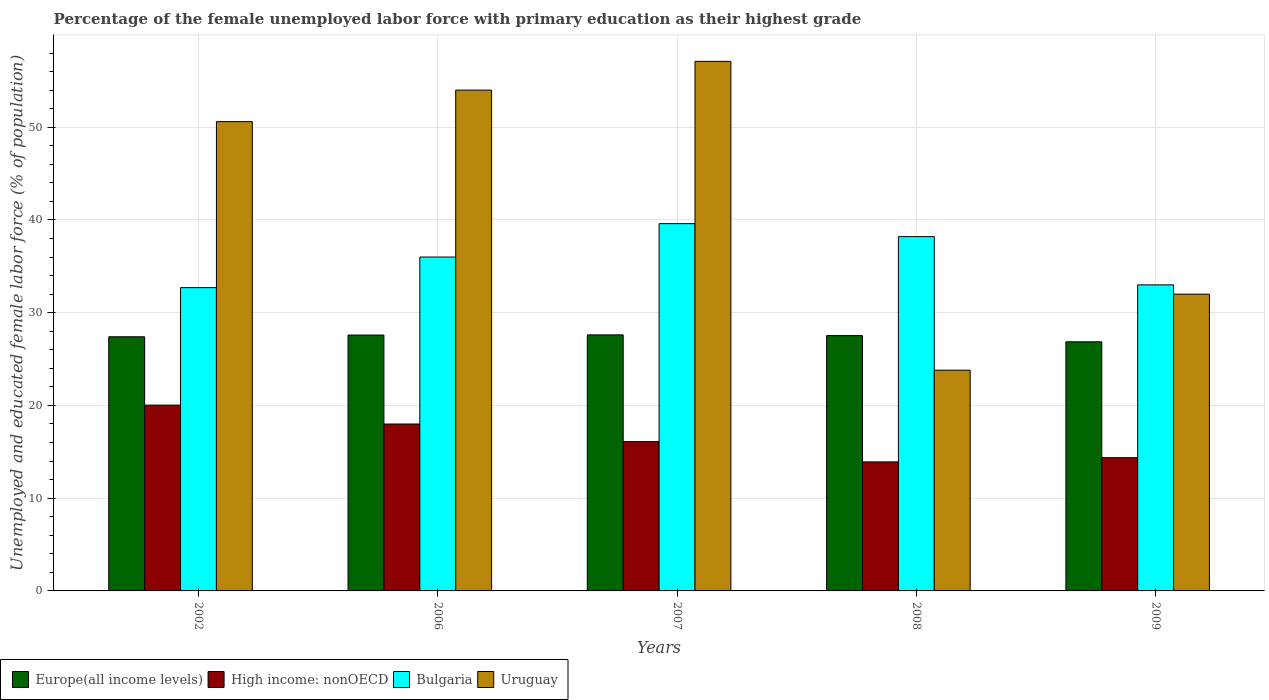How many different coloured bars are there?
Your answer should be very brief. 4. How many groups of bars are there?
Make the answer very short. 5. Are the number of bars on each tick of the X-axis equal?
Make the answer very short. Yes. How many bars are there on the 3rd tick from the right?
Ensure brevity in your answer.  4. What is the percentage of the unemployed female labor force with primary education in Bulgaria in 2002?
Provide a succinct answer. 32.7. Across all years, what is the maximum percentage of the unemployed female labor force with primary education in Uruguay?
Give a very brief answer. 57.1. Across all years, what is the minimum percentage of the unemployed female labor force with primary education in Uruguay?
Offer a terse response. 23.8. In which year was the percentage of the unemployed female labor force with primary education in Bulgaria maximum?
Provide a short and direct response. 2007. What is the total percentage of the unemployed female labor force with primary education in Europe(all income levels) in the graph?
Give a very brief answer. 136.99. What is the difference between the percentage of the unemployed female labor force with primary education in Uruguay in 2006 and that in 2009?
Give a very brief answer. 22. What is the difference between the percentage of the unemployed female labor force with primary education in Uruguay in 2007 and the percentage of the unemployed female labor force with primary education in Bulgaria in 2009?
Offer a terse response. 24.1. What is the average percentage of the unemployed female labor force with primary education in Europe(all income levels) per year?
Provide a succinct answer. 27.4. In the year 2009, what is the difference between the percentage of the unemployed female labor force with primary education in Bulgaria and percentage of the unemployed female labor force with primary education in Europe(all income levels)?
Your response must be concise. 6.14. In how many years, is the percentage of the unemployed female labor force with primary education in Uruguay greater than 42 %?
Give a very brief answer. 3. What is the ratio of the percentage of the unemployed female labor force with primary education in Bulgaria in 2006 to that in 2007?
Keep it short and to the point. 0.91. What is the difference between the highest and the second highest percentage of the unemployed female labor force with primary education in Bulgaria?
Give a very brief answer. 1.4. What is the difference between the highest and the lowest percentage of the unemployed female labor force with primary education in Europe(all income levels)?
Keep it short and to the point. 0.75. In how many years, is the percentage of the unemployed female labor force with primary education in Europe(all income levels) greater than the average percentage of the unemployed female labor force with primary education in Europe(all income levels) taken over all years?
Make the answer very short. 4. Is the sum of the percentage of the unemployed female labor force with primary education in High income: nonOECD in 2007 and 2009 greater than the maximum percentage of the unemployed female labor force with primary education in Bulgaria across all years?
Ensure brevity in your answer.  No. What does the 2nd bar from the left in 2007 represents?
Offer a terse response. High income: nonOECD. What does the 4th bar from the right in 2009 represents?
Offer a very short reply. Europe(all income levels). Is it the case that in every year, the sum of the percentage of the unemployed female labor force with primary education in Europe(all income levels) and percentage of the unemployed female labor force with primary education in Uruguay is greater than the percentage of the unemployed female labor force with primary education in Bulgaria?
Your answer should be very brief. Yes. How many bars are there?
Offer a terse response. 20. Are all the bars in the graph horizontal?
Keep it short and to the point. No. What is the difference between two consecutive major ticks on the Y-axis?
Your answer should be very brief. 10. Are the values on the major ticks of Y-axis written in scientific E-notation?
Keep it short and to the point. No. Where does the legend appear in the graph?
Provide a short and direct response. Bottom left. How many legend labels are there?
Your answer should be very brief. 4. What is the title of the graph?
Your answer should be very brief. Percentage of the female unemployed labor force with primary education as their highest grade. What is the label or title of the Y-axis?
Make the answer very short. Unemployed and educated female labor force (% of population). What is the Unemployed and educated female labor force (% of population) of Europe(all income levels) in 2002?
Provide a short and direct response. 27.4. What is the Unemployed and educated female labor force (% of population) in High income: nonOECD in 2002?
Your answer should be compact. 20.04. What is the Unemployed and educated female labor force (% of population) in Bulgaria in 2002?
Provide a succinct answer. 32.7. What is the Unemployed and educated female labor force (% of population) of Uruguay in 2002?
Provide a short and direct response. 50.6. What is the Unemployed and educated female labor force (% of population) in Europe(all income levels) in 2006?
Give a very brief answer. 27.59. What is the Unemployed and educated female labor force (% of population) of High income: nonOECD in 2006?
Ensure brevity in your answer.  18. What is the Unemployed and educated female labor force (% of population) of Bulgaria in 2006?
Provide a succinct answer. 36. What is the Unemployed and educated female labor force (% of population) of Europe(all income levels) in 2007?
Ensure brevity in your answer.  27.61. What is the Unemployed and educated female labor force (% of population) of High income: nonOECD in 2007?
Offer a terse response. 16.1. What is the Unemployed and educated female labor force (% of population) in Bulgaria in 2007?
Offer a very short reply. 39.6. What is the Unemployed and educated female labor force (% of population) in Uruguay in 2007?
Give a very brief answer. 57.1. What is the Unemployed and educated female labor force (% of population) of Europe(all income levels) in 2008?
Your answer should be compact. 27.53. What is the Unemployed and educated female labor force (% of population) in High income: nonOECD in 2008?
Offer a terse response. 13.91. What is the Unemployed and educated female labor force (% of population) of Bulgaria in 2008?
Your answer should be very brief. 38.2. What is the Unemployed and educated female labor force (% of population) in Uruguay in 2008?
Make the answer very short. 23.8. What is the Unemployed and educated female labor force (% of population) in Europe(all income levels) in 2009?
Keep it short and to the point. 26.86. What is the Unemployed and educated female labor force (% of population) in High income: nonOECD in 2009?
Your answer should be very brief. 14.37. What is the Unemployed and educated female labor force (% of population) of Uruguay in 2009?
Provide a succinct answer. 32. Across all years, what is the maximum Unemployed and educated female labor force (% of population) in Europe(all income levels)?
Offer a terse response. 27.61. Across all years, what is the maximum Unemployed and educated female labor force (% of population) of High income: nonOECD?
Offer a terse response. 20.04. Across all years, what is the maximum Unemployed and educated female labor force (% of population) of Bulgaria?
Give a very brief answer. 39.6. Across all years, what is the maximum Unemployed and educated female labor force (% of population) in Uruguay?
Your answer should be very brief. 57.1. Across all years, what is the minimum Unemployed and educated female labor force (% of population) of Europe(all income levels)?
Your answer should be very brief. 26.86. Across all years, what is the minimum Unemployed and educated female labor force (% of population) in High income: nonOECD?
Keep it short and to the point. 13.91. Across all years, what is the minimum Unemployed and educated female labor force (% of population) of Bulgaria?
Offer a terse response. 32.7. Across all years, what is the minimum Unemployed and educated female labor force (% of population) in Uruguay?
Your response must be concise. 23.8. What is the total Unemployed and educated female labor force (% of population) of Europe(all income levels) in the graph?
Keep it short and to the point. 136.99. What is the total Unemployed and educated female labor force (% of population) in High income: nonOECD in the graph?
Keep it short and to the point. 82.41. What is the total Unemployed and educated female labor force (% of population) of Bulgaria in the graph?
Give a very brief answer. 179.5. What is the total Unemployed and educated female labor force (% of population) of Uruguay in the graph?
Your answer should be compact. 217.5. What is the difference between the Unemployed and educated female labor force (% of population) in Europe(all income levels) in 2002 and that in 2006?
Offer a very short reply. -0.18. What is the difference between the Unemployed and educated female labor force (% of population) in High income: nonOECD in 2002 and that in 2006?
Your answer should be compact. 2.04. What is the difference between the Unemployed and educated female labor force (% of population) of Bulgaria in 2002 and that in 2006?
Your answer should be very brief. -3.3. What is the difference between the Unemployed and educated female labor force (% of population) of Uruguay in 2002 and that in 2006?
Provide a succinct answer. -3.4. What is the difference between the Unemployed and educated female labor force (% of population) of Europe(all income levels) in 2002 and that in 2007?
Your response must be concise. -0.2. What is the difference between the Unemployed and educated female labor force (% of population) in High income: nonOECD in 2002 and that in 2007?
Your answer should be compact. 3.94. What is the difference between the Unemployed and educated female labor force (% of population) in Uruguay in 2002 and that in 2007?
Your response must be concise. -6.5. What is the difference between the Unemployed and educated female labor force (% of population) in Europe(all income levels) in 2002 and that in 2008?
Offer a terse response. -0.12. What is the difference between the Unemployed and educated female labor force (% of population) in High income: nonOECD in 2002 and that in 2008?
Make the answer very short. 6.12. What is the difference between the Unemployed and educated female labor force (% of population) in Uruguay in 2002 and that in 2008?
Your answer should be compact. 26.8. What is the difference between the Unemployed and educated female labor force (% of population) in Europe(all income levels) in 2002 and that in 2009?
Make the answer very short. 0.54. What is the difference between the Unemployed and educated female labor force (% of population) of High income: nonOECD in 2002 and that in 2009?
Your answer should be very brief. 5.67. What is the difference between the Unemployed and educated female labor force (% of population) in Uruguay in 2002 and that in 2009?
Your answer should be very brief. 18.6. What is the difference between the Unemployed and educated female labor force (% of population) of Europe(all income levels) in 2006 and that in 2007?
Provide a succinct answer. -0.02. What is the difference between the Unemployed and educated female labor force (% of population) of High income: nonOECD in 2006 and that in 2007?
Ensure brevity in your answer.  1.9. What is the difference between the Unemployed and educated female labor force (% of population) in Europe(all income levels) in 2006 and that in 2008?
Keep it short and to the point. 0.06. What is the difference between the Unemployed and educated female labor force (% of population) of High income: nonOECD in 2006 and that in 2008?
Your response must be concise. 4.09. What is the difference between the Unemployed and educated female labor force (% of population) of Uruguay in 2006 and that in 2008?
Your response must be concise. 30.2. What is the difference between the Unemployed and educated female labor force (% of population) in Europe(all income levels) in 2006 and that in 2009?
Provide a short and direct response. 0.73. What is the difference between the Unemployed and educated female labor force (% of population) of High income: nonOECD in 2006 and that in 2009?
Your response must be concise. 3.63. What is the difference between the Unemployed and educated female labor force (% of population) of Bulgaria in 2006 and that in 2009?
Your response must be concise. 3. What is the difference between the Unemployed and educated female labor force (% of population) in Uruguay in 2006 and that in 2009?
Ensure brevity in your answer.  22. What is the difference between the Unemployed and educated female labor force (% of population) of Europe(all income levels) in 2007 and that in 2008?
Provide a short and direct response. 0.08. What is the difference between the Unemployed and educated female labor force (% of population) in High income: nonOECD in 2007 and that in 2008?
Provide a succinct answer. 2.19. What is the difference between the Unemployed and educated female labor force (% of population) in Bulgaria in 2007 and that in 2008?
Your response must be concise. 1.4. What is the difference between the Unemployed and educated female labor force (% of population) in Uruguay in 2007 and that in 2008?
Provide a succinct answer. 33.3. What is the difference between the Unemployed and educated female labor force (% of population) of Europe(all income levels) in 2007 and that in 2009?
Your answer should be compact. 0.75. What is the difference between the Unemployed and educated female labor force (% of population) in High income: nonOECD in 2007 and that in 2009?
Offer a terse response. 1.73. What is the difference between the Unemployed and educated female labor force (% of population) in Uruguay in 2007 and that in 2009?
Give a very brief answer. 25.1. What is the difference between the Unemployed and educated female labor force (% of population) in Europe(all income levels) in 2008 and that in 2009?
Keep it short and to the point. 0.67. What is the difference between the Unemployed and educated female labor force (% of population) of High income: nonOECD in 2008 and that in 2009?
Offer a very short reply. -0.45. What is the difference between the Unemployed and educated female labor force (% of population) in Europe(all income levels) in 2002 and the Unemployed and educated female labor force (% of population) in High income: nonOECD in 2006?
Offer a very short reply. 9.41. What is the difference between the Unemployed and educated female labor force (% of population) of Europe(all income levels) in 2002 and the Unemployed and educated female labor force (% of population) of Bulgaria in 2006?
Ensure brevity in your answer.  -8.6. What is the difference between the Unemployed and educated female labor force (% of population) of Europe(all income levels) in 2002 and the Unemployed and educated female labor force (% of population) of Uruguay in 2006?
Give a very brief answer. -26.6. What is the difference between the Unemployed and educated female labor force (% of population) of High income: nonOECD in 2002 and the Unemployed and educated female labor force (% of population) of Bulgaria in 2006?
Provide a succinct answer. -15.96. What is the difference between the Unemployed and educated female labor force (% of population) of High income: nonOECD in 2002 and the Unemployed and educated female labor force (% of population) of Uruguay in 2006?
Ensure brevity in your answer.  -33.96. What is the difference between the Unemployed and educated female labor force (% of population) in Bulgaria in 2002 and the Unemployed and educated female labor force (% of population) in Uruguay in 2006?
Offer a terse response. -21.3. What is the difference between the Unemployed and educated female labor force (% of population) in Europe(all income levels) in 2002 and the Unemployed and educated female labor force (% of population) in High income: nonOECD in 2007?
Make the answer very short. 11.3. What is the difference between the Unemployed and educated female labor force (% of population) of Europe(all income levels) in 2002 and the Unemployed and educated female labor force (% of population) of Bulgaria in 2007?
Provide a short and direct response. -12.2. What is the difference between the Unemployed and educated female labor force (% of population) in Europe(all income levels) in 2002 and the Unemployed and educated female labor force (% of population) in Uruguay in 2007?
Your answer should be very brief. -29.7. What is the difference between the Unemployed and educated female labor force (% of population) in High income: nonOECD in 2002 and the Unemployed and educated female labor force (% of population) in Bulgaria in 2007?
Your answer should be compact. -19.56. What is the difference between the Unemployed and educated female labor force (% of population) of High income: nonOECD in 2002 and the Unemployed and educated female labor force (% of population) of Uruguay in 2007?
Your answer should be very brief. -37.06. What is the difference between the Unemployed and educated female labor force (% of population) in Bulgaria in 2002 and the Unemployed and educated female labor force (% of population) in Uruguay in 2007?
Offer a very short reply. -24.4. What is the difference between the Unemployed and educated female labor force (% of population) of Europe(all income levels) in 2002 and the Unemployed and educated female labor force (% of population) of High income: nonOECD in 2008?
Your answer should be very brief. 13.49. What is the difference between the Unemployed and educated female labor force (% of population) in Europe(all income levels) in 2002 and the Unemployed and educated female labor force (% of population) in Bulgaria in 2008?
Offer a terse response. -10.8. What is the difference between the Unemployed and educated female labor force (% of population) in Europe(all income levels) in 2002 and the Unemployed and educated female labor force (% of population) in Uruguay in 2008?
Provide a succinct answer. 3.6. What is the difference between the Unemployed and educated female labor force (% of population) in High income: nonOECD in 2002 and the Unemployed and educated female labor force (% of population) in Bulgaria in 2008?
Ensure brevity in your answer.  -18.16. What is the difference between the Unemployed and educated female labor force (% of population) in High income: nonOECD in 2002 and the Unemployed and educated female labor force (% of population) in Uruguay in 2008?
Provide a short and direct response. -3.76. What is the difference between the Unemployed and educated female labor force (% of population) in Bulgaria in 2002 and the Unemployed and educated female labor force (% of population) in Uruguay in 2008?
Provide a succinct answer. 8.9. What is the difference between the Unemployed and educated female labor force (% of population) of Europe(all income levels) in 2002 and the Unemployed and educated female labor force (% of population) of High income: nonOECD in 2009?
Make the answer very short. 13.04. What is the difference between the Unemployed and educated female labor force (% of population) in Europe(all income levels) in 2002 and the Unemployed and educated female labor force (% of population) in Bulgaria in 2009?
Your answer should be compact. -5.6. What is the difference between the Unemployed and educated female labor force (% of population) of Europe(all income levels) in 2002 and the Unemployed and educated female labor force (% of population) of Uruguay in 2009?
Offer a terse response. -4.6. What is the difference between the Unemployed and educated female labor force (% of population) in High income: nonOECD in 2002 and the Unemployed and educated female labor force (% of population) in Bulgaria in 2009?
Offer a very short reply. -12.96. What is the difference between the Unemployed and educated female labor force (% of population) in High income: nonOECD in 2002 and the Unemployed and educated female labor force (% of population) in Uruguay in 2009?
Provide a short and direct response. -11.96. What is the difference between the Unemployed and educated female labor force (% of population) of Europe(all income levels) in 2006 and the Unemployed and educated female labor force (% of population) of High income: nonOECD in 2007?
Make the answer very short. 11.49. What is the difference between the Unemployed and educated female labor force (% of population) of Europe(all income levels) in 2006 and the Unemployed and educated female labor force (% of population) of Bulgaria in 2007?
Offer a very short reply. -12.01. What is the difference between the Unemployed and educated female labor force (% of population) of Europe(all income levels) in 2006 and the Unemployed and educated female labor force (% of population) of Uruguay in 2007?
Your answer should be compact. -29.51. What is the difference between the Unemployed and educated female labor force (% of population) in High income: nonOECD in 2006 and the Unemployed and educated female labor force (% of population) in Bulgaria in 2007?
Provide a short and direct response. -21.6. What is the difference between the Unemployed and educated female labor force (% of population) of High income: nonOECD in 2006 and the Unemployed and educated female labor force (% of population) of Uruguay in 2007?
Give a very brief answer. -39.1. What is the difference between the Unemployed and educated female labor force (% of population) of Bulgaria in 2006 and the Unemployed and educated female labor force (% of population) of Uruguay in 2007?
Provide a succinct answer. -21.1. What is the difference between the Unemployed and educated female labor force (% of population) in Europe(all income levels) in 2006 and the Unemployed and educated female labor force (% of population) in High income: nonOECD in 2008?
Provide a short and direct response. 13.68. What is the difference between the Unemployed and educated female labor force (% of population) of Europe(all income levels) in 2006 and the Unemployed and educated female labor force (% of population) of Bulgaria in 2008?
Your response must be concise. -10.61. What is the difference between the Unemployed and educated female labor force (% of population) of Europe(all income levels) in 2006 and the Unemployed and educated female labor force (% of population) of Uruguay in 2008?
Your answer should be compact. 3.79. What is the difference between the Unemployed and educated female labor force (% of population) in High income: nonOECD in 2006 and the Unemployed and educated female labor force (% of population) in Bulgaria in 2008?
Provide a succinct answer. -20.2. What is the difference between the Unemployed and educated female labor force (% of population) in High income: nonOECD in 2006 and the Unemployed and educated female labor force (% of population) in Uruguay in 2008?
Your answer should be very brief. -5.8. What is the difference between the Unemployed and educated female labor force (% of population) of Bulgaria in 2006 and the Unemployed and educated female labor force (% of population) of Uruguay in 2008?
Give a very brief answer. 12.2. What is the difference between the Unemployed and educated female labor force (% of population) of Europe(all income levels) in 2006 and the Unemployed and educated female labor force (% of population) of High income: nonOECD in 2009?
Offer a terse response. 13.22. What is the difference between the Unemployed and educated female labor force (% of population) in Europe(all income levels) in 2006 and the Unemployed and educated female labor force (% of population) in Bulgaria in 2009?
Offer a terse response. -5.41. What is the difference between the Unemployed and educated female labor force (% of population) in Europe(all income levels) in 2006 and the Unemployed and educated female labor force (% of population) in Uruguay in 2009?
Provide a short and direct response. -4.41. What is the difference between the Unemployed and educated female labor force (% of population) of High income: nonOECD in 2006 and the Unemployed and educated female labor force (% of population) of Bulgaria in 2009?
Make the answer very short. -15. What is the difference between the Unemployed and educated female labor force (% of population) of High income: nonOECD in 2006 and the Unemployed and educated female labor force (% of population) of Uruguay in 2009?
Your answer should be compact. -14. What is the difference between the Unemployed and educated female labor force (% of population) in Bulgaria in 2006 and the Unemployed and educated female labor force (% of population) in Uruguay in 2009?
Offer a terse response. 4. What is the difference between the Unemployed and educated female labor force (% of population) in Europe(all income levels) in 2007 and the Unemployed and educated female labor force (% of population) in High income: nonOECD in 2008?
Your answer should be very brief. 13.7. What is the difference between the Unemployed and educated female labor force (% of population) in Europe(all income levels) in 2007 and the Unemployed and educated female labor force (% of population) in Bulgaria in 2008?
Your answer should be very brief. -10.59. What is the difference between the Unemployed and educated female labor force (% of population) in Europe(all income levels) in 2007 and the Unemployed and educated female labor force (% of population) in Uruguay in 2008?
Give a very brief answer. 3.81. What is the difference between the Unemployed and educated female labor force (% of population) in High income: nonOECD in 2007 and the Unemployed and educated female labor force (% of population) in Bulgaria in 2008?
Your answer should be very brief. -22.1. What is the difference between the Unemployed and educated female labor force (% of population) in High income: nonOECD in 2007 and the Unemployed and educated female labor force (% of population) in Uruguay in 2008?
Your answer should be very brief. -7.7. What is the difference between the Unemployed and educated female labor force (% of population) of Bulgaria in 2007 and the Unemployed and educated female labor force (% of population) of Uruguay in 2008?
Provide a short and direct response. 15.8. What is the difference between the Unemployed and educated female labor force (% of population) of Europe(all income levels) in 2007 and the Unemployed and educated female labor force (% of population) of High income: nonOECD in 2009?
Your response must be concise. 13.24. What is the difference between the Unemployed and educated female labor force (% of population) in Europe(all income levels) in 2007 and the Unemployed and educated female labor force (% of population) in Bulgaria in 2009?
Keep it short and to the point. -5.39. What is the difference between the Unemployed and educated female labor force (% of population) of Europe(all income levels) in 2007 and the Unemployed and educated female labor force (% of population) of Uruguay in 2009?
Your answer should be very brief. -4.39. What is the difference between the Unemployed and educated female labor force (% of population) in High income: nonOECD in 2007 and the Unemployed and educated female labor force (% of population) in Bulgaria in 2009?
Offer a terse response. -16.9. What is the difference between the Unemployed and educated female labor force (% of population) of High income: nonOECD in 2007 and the Unemployed and educated female labor force (% of population) of Uruguay in 2009?
Ensure brevity in your answer.  -15.9. What is the difference between the Unemployed and educated female labor force (% of population) of Bulgaria in 2007 and the Unemployed and educated female labor force (% of population) of Uruguay in 2009?
Offer a terse response. 7.6. What is the difference between the Unemployed and educated female labor force (% of population) in Europe(all income levels) in 2008 and the Unemployed and educated female labor force (% of population) in High income: nonOECD in 2009?
Your answer should be very brief. 13.16. What is the difference between the Unemployed and educated female labor force (% of population) of Europe(all income levels) in 2008 and the Unemployed and educated female labor force (% of population) of Bulgaria in 2009?
Your response must be concise. -5.47. What is the difference between the Unemployed and educated female labor force (% of population) of Europe(all income levels) in 2008 and the Unemployed and educated female labor force (% of population) of Uruguay in 2009?
Offer a very short reply. -4.47. What is the difference between the Unemployed and educated female labor force (% of population) of High income: nonOECD in 2008 and the Unemployed and educated female labor force (% of population) of Bulgaria in 2009?
Make the answer very short. -19.09. What is the difference between the Unemployed and educated female labor force (% of population) of High income: nonOECD in 2008 and the Unemployed and educated female labor force (% of population) of Uruguay in 2009?
Provide a short and direct response. -18.09. What is the difference between the Unemployed and educated female labor force (% of population) of Bulgaria in 2008 and the Unemployed and educated female labor force (% of population) of Uruguay in 2009?
Ensure brevity in your answer.  6.2. What is the average Unemployed and educated female labor force (% of population) in Europe(all income levels) per year?
Your answer should be compact. 27.4. What is the average Unemployed and educated female labor force (% of population) in High income: nonOECD per year?
Offer a very short reply. 16.48. What is the average Unemployed and educated female labor force (% of population) in Bulgaria per year?
Your response must be concise. 35.9. What is the average Unemployed and educated female labor force (% of population) in Uruguay per year?
Your answer should be compact. 43.5. In the year 2002, what is the difference between the Unemployed and educated female labor force (% of population) in Europe(all income levels) and Unemployed and educated female labor force (% of population) in High income: nonOECD?
Offer a very short reply. 7.37. In the year 2002, what is the difference between the Unemployed and educated female labor force (% of population) of Europe(all income levels) and Unemployed and educated female labor force (% of population) of Bulgaria?
Your response must be concise. -5.3. In the year 2002, what is the difference between the Unemployed and educated female labor force (% of population) in Europe(all income levels) and Unemployed and educated female labor force (% of population) in Uruguay?
Provide a short and direct response. -23.2. In the year 2002, what is the difference between the Unemployed and educated female labor force (% of population) in High income: nonOECD and Unemployed and educated female labor force (% of population) in Bulgaria?
Make the answer very short. -12.66. In the year 2002, what is the difference between the Unemployed and educated female labor force (% of population) of High income: nonOECD and Unemployed and educated female labor force (% of population) of Uruguay?
Ensure brevity in your answer.  -30.56. In the year 2002, what is the difference between the Unemployed and educated female labor force (% of population) in Bulgaria and Unemployed and educated female labor force (% of population) in Uruguay?
Offer a terse response. -17.9. In the year 2006, what is the difference between the Unemployed and educated female labor force (% of population) of Europe(all income levels) and Unemployed and educated female labor force (% of population) of High income: nonOECD?
Provide a succinct answer. 9.59. In the year 2006, what is the difference between the Unemployed and educated female labor force (% of population) in Europe(all income levels) and Unemployed and educated female labor force (% of population) in Bulgaria?
Your answer should be very brief. -8.41. In the year 2006, what is the difference between the Unemployed and educated female labor force (% of population) in Europe(all income levels) and Unemployed and educated female labor force (% of population) in Uruguay?
Your answer should be very brief. -26.41. In the year 2006, what is the difference between the Unemployed and educated female labor force (% of population) of High income: nonOECD and Unemployed and educated female labor force (% of population) of Bulgaria?
Provide a short and direct response. -18. In the year 2006, what is the difference between the Unemployed and educated female labor force (% of population) of High income: nonOECD and Unemployed and educated female labor force (% of population) of Uruguay?
Ensure brevity in your answer.  -36. In the year 2006, what is the difference between the Unemployed and educated female labor force (% of population) in Bulgaria and Unemployed and educated female labor force (% of population) in Uruguay?
Your answer should be compact. -18. In the year 2007, what is the difference between the Unemployed and educated female labor force (% of population) in Europe(all income levels) and Unemployed and educated female labor force (% of population) in High income: nonOECD?
Make the answer very short. 11.51. In the year 2007, what is the difference between the Unemployed and educated female labor force (% of population) in Europe(all income levels) and Unemployed and educated female labor force (% of population) in Bulgaria?
Ensure brevity in your answer.  -11.99. In the year 2007, what is the difference between the Unemployed and educated female labor force (% of population) in Europe(all income levels) and Unemployed and educated female labor force (% of population) in Uruguay?
Make the answer very short. -29.49. In the year 2007, what is the difference between the Unemployed and educated female labor force (% of population) in High income: nonOECD and Unemployed and educated female labor force (% of population) in Bulgaria?
Make the answer very short. -23.5. In the year 2007, what is the difference between the Unemployed and educated female labor force (% of population) of High income: nonOECD and Unemployed and educated female labor force (% of population) of Uruguay?
Ensure brevity in your answer.  -41. In the year 2007, what is the difference between the Unemployed and educated female labor force (% of population) in Bulgaria and Unemployed and educated female labor force (% of population) in Uruguay?
Provide a succinct answer. -17.5. In the year 2008, what is the difference between the Unemployed and educated female labor force (% of population) in Europe(all income levels) and Unemployed and educated female labor force (% of population) in High income: nonOECD?
Make the answer very short. 13.62. In the year 2008, what is the difference between the Unemployed and educated female labor force (% of population) of Europe(all income levels) and Unemployed and educated female labor force (% of population) of Bulgaria?
Provide a short and direct response. -10.67. In the year 2008, what is the difference between the Unemployed and educated female labor force (% of population) of Europe(all income levels) and Unemployed and educated female labor force (% of population) of Uruguay?
Offer a terse response. 3.73. In the year 2008, what is the difference between the Unemployed and educated female labor force (% of population) of High income: nonOECD and Unemployed and educated female labor force (% of population) of Bulgaria?
Your answer should be very brief. -24.29. In the year 2008, what is the difference between the Unemployed and educated female labor force (% of population) in High income: nonOECD and Unemployed and educated female labor force (% of population) in Uruguay?
Provide a short and direct response. -9.89. In the year 2008, what is the difference between the Unemployed and educated female labor force (% of population) in Bulgaria and Unemployed and educated female labor force (% of population) in Uruguay?
Give a very brief answer. 14.4. In the year 2009, what is the difference between the Unemployed and educated female labor force (% of population) in Europe(all income levels) and Unemployed and educated female labor force (% of population) in High income: nonOECD?
Provide a succinct answer. 12.49. In the year 2009, what is the difference between the Unemployed and educated female labor force (% of population) in Europe(all income levels) and Unemployed and educated female labor force (% of population) in Bulgaria?
Offer a terse response. -6.14. In the year 2009, what is the difference between the Unemployed and educated female labor force (% of population) of Europe(all income levels) and Unemployed and educated female labor force (% of population) of Uruguay?
Make the answer very short. -5.14. In the year 2009, what is the difference between the Unemployed and educated female labor force (% of population) of High income: nonOECD and Unemployed and educated female labor force (% of population) of Bulgaria?
Your answer should be compact. -18.63. In the year 2009, what is the difference between the Unemployed and educated female labor force (% of population) of High income: nonOECD and Unemployed and educated female labor force (% of population) of Uruguay?
Your answer should be very brief. -17.63. In the year 2009, what is the difference between the Unemployed and educated female labor force (% of population) of Bulgaria and Unemployed and educated female labor force (% of population) of Uruguay?
Provide a short and direct response. 1. What is the ratio of the Unemployed and educated female labor force (% of population) in High income: nonOECD in 2002 to that in 2006?
Your answer should be very brief. 1.11. What is the ratio of the Unemployed and educated female labor force (% of population) in Bulgaria in 2002 to that in 2006?
Ensure brevity in your answer.  0.91. What is the ratio of the Unemployed and educated female labor force (% of population) of Uruguay in 2002 to that in 2006?
Provide a short and direct response. 0.94. What is the ratio of the Unemployed and educated female labor force (% of population) of Europe(all income levels) in 2002 to that in 2007?
Your answer should be very brief. 0.99. What is the ratio of the Unemployed and educated female labor force (% of population) in High income: nonOECD in 2002 to that in 2007?
Your answer should be very brief. 1.24. What is the ratio of the Unemployed and educated female labor force (% of population) of Bulgaria in 2002 to that in 2007?
Your answer should be compact. 0.83. What is the ratio of the Unemployed and educated female labor force (% of population) of Uruguay in 2002 to that in 2007?
Ensure brevity in your answer.  0.89. What is the ratio of the Unemployed and educated female labor force (% of population) of High income: nonOECD in 2002 to that in 2008?
Ensure brevity in your answer.  1.44. What is the ratio of the Unemployed and educated female labor force (% of population) of Bulgaria in 2002 to that in 2008?
Ensure brevity in your answer.  0.86. What is the ratio of the Unemployed and educated female labor force (% of population) in Uruguay in 2002 to that in 2008?
Make the answer very short. 2.13. What is the ratio of the Unemployed and educated female labor force (% of population) of Europe(all income levels) in 2002 to that in 2009?
Ensure brevity in your answer.  1.02. What is the ratio of the Unemployed and educated female labor force (% of population) in High income: nonOECD in 2002 to that in 2009?
Your response must be concise. 1.39. What is the ratio of the Unemployed and educated female labor force (% of population) of Bulgaria in 2002 to that in 2009?
Provide a succinct answer. 0.99. What is the ratio of the Unemployed and educated female labor force (% of population) of Uruguay in 2002 to that in 2009?
Your response must be concise. 1.58. What is the ratio of the Unemployed and educated female labor force (% of population) of Europe(all income levels) in 2006 to that in 2007?
Your answer should be compact. 1. What is the ratio of the Unemployed and educated female labor force (% of population) of High income: nonOECD in 2006 to that in 2007?
Offer a terse response. 1.12. What is the ratio of the Unemployed and educated female labor force (% of population) of Bulgaria in 2006 to that in 2007?
Your answer should be very brief. 0.91. What is the ratio of the Unemployed and educated female labor force (% of population) of Uruguay in 2006 to that in 2007?
Give a very brief answer. 0.95. What is the ratio of the Unemployed and educated female labor force (% of population) of Europe(all income levels) in 2006 to that in 2008?
Make the answer very short. 1. What is the ratio of the Unemployed and educated female labor force (% of population) in High income: nonOECD in 2006 to that in 2008?
Provide a short and direct response. 1.29. What is the ratio of the Unemployed and educated female labor force (% of population) of Bulgaria in 2006 to that in 2008?
Your response must be concise. 0.94. What is the ratio of the Unemployed and educated female labor force (% of population) of Uruguay in 2006 to that in 2008?
Offer a very short reply. 2.27. What is the ratio of the Unemployed and educated female labor force (% of population) in Europe(all income levels) in 2006 to that in 2009?
Provide a succinct answer. 1.03. What is the ratio of the Unemployed and educated female labor force (% of population) in High income: nonOECD in 2006 to that in 2009?
Your answer should be very brief. 1.25. What is the ratio of the Unemployed and educated female labor force (% of population) of Bulgaria in 2006 to that in 2009?
Provide a succinct answer. 1.09. What is the ratio of the Unemployed and educated female labor force (% of population) of Uruguay in 2006 to that in 2009?
Offer a terse response. 1.69. What is the ratio of the Unemployed and educated female labor force (% of population) of Europe(all income levels) in 2007 to that in 2008?
Ensure brevity in your answer.  1. What is the ratio of the Unemployed and educated female labor force (% of population) in High income: nonOECD in 2007 to that in 2008?
Provide a short and direct response. 1.16. What is the ratio of the Unemployed and educated female labor force (% of population) in Bulgaria in 2007 to that in 2008?
Ensure brevity in your answer.  1.04. What is the ratio of the Unemployed and educated female labor force (% of population) in Uruguay in 2007 to that in 2008?
Provide a short and direct response. 2.4. What is the ratio of the Unemployed and educated female labor force (% of population) in Europe(all income levels) in 2007 to that in 2009?
Give a very brief answer. 1.03. What is the ratio of the Unemployed and educated female labor force (% of population) of High income: nonOECD in 2007 to that in 2009?
Your answer should be very brief. 1.12. What is the ratio of the Unemployed and educated female labor force (% of population) in Bulgaria in 2007 to that in 2009?
Your response must be concise. 1.2. What is the ratio of the Unemployed and educated female labor force (% of population) in Uruguay in 2007 to that in 2009?
Offer a very short reply. 1.78. What is the ratio of the Unemployed and educated female labor force (% of population) in Europe(all income levels) in 2008 to that in 2009?
Offer a very short reply. 1.02. What is the ratio of the Unemployed and educated female labor force (% of population) in High income: nonOECD in 2008 to that in 2009?
Ensure brevity in your answer.  0.97. What is the ratio of the Unemployed and educated female labor force (% of population) in Bulgaria in 2008 to that in 2009?
Offer a very short reply. 1.16. What is the ratio of the Unemployed and educated female labor force (% of population) of Uruguay in 2008 to that in 2009?
Your answer should be compact. 0.74. What is the difference between the highest and the second highest Unemployed and educated female labor force (% of population) of Europe(all income levels)?
Offer a very short reply. 0.02. What is the difference between the highest and the second highest Unemployed and educated female labor force (% of population) in High income: nonOECD?
Make the answer very short. 2.04. What is the difference between the highest and the lowest Unemployed and educated female labor force (% of population) of Europe(all income levels)?
Your answer should be very brief. 0.75. What is the difference between the highest and the lowest Unemployed and educated female labor force (% of population) in High income: nonOECD?
Offer a very short reply. 6.12. What is the difference between the highest and the lowest Unemployed and educated female labor force (% of population) of Bulgaria?
Offer a terse response. 6.9. What is the difference between the highest and the lowest Unemployed and educated female labor force (% of population) of Uruguay?
Ensure brevity in your answer.  33.3. 